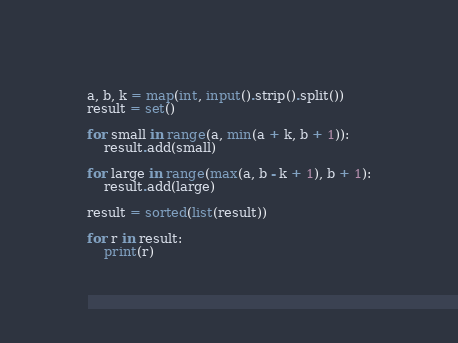Convert code to text. <code><loc_0><loc_0><loc_500><loc_500><_Python_>a, b, k = map(int, input().strip().split())
result = set()

for small in range(a, min(a + k, b + 1)):
    result.add(small)

for large in range(max(a, b - k + 1), b + 1):
    result.add(large)

result = sorted(list(result))

for r in result:
    print(r)
</code> 